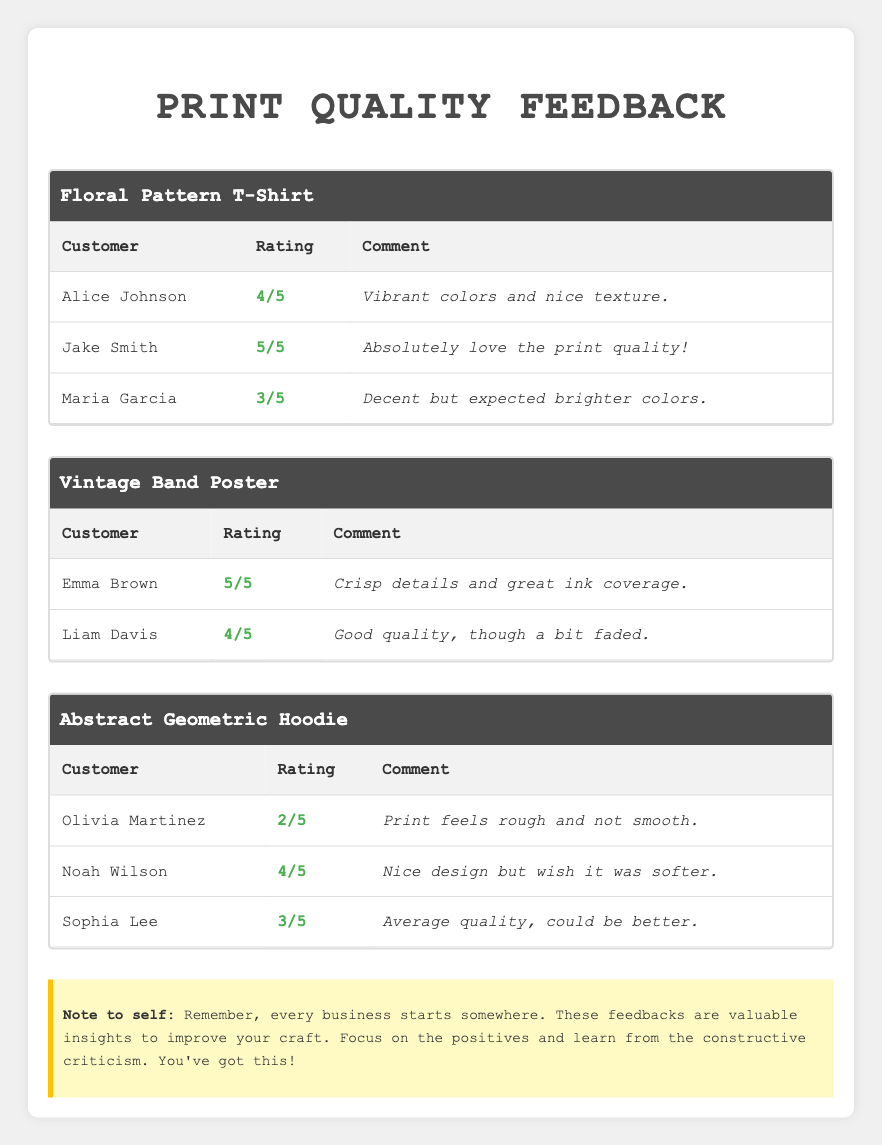What is the highest rating given to a design? The highest rating in the feedback table is 5, which was given by Jake Smith for the 'Floral Pattern T-Shirt' and by Emma Brown for the 'Vintage Band Poster'.
Answer: 5 How many customer feedbacks are there for the 'Abstract Geometric Hoodie'? There are three customer feedback entries for the 'Abstract Geometric Hoodie', from Olivia Martinez, Noah Wilson, and Sophia Lee.
Answer: 3 Which design received an average rating of 3 or higher? To find this out, we sum the ratings for each design. 'Floral Pattern T-Shirt' has ratings of 4, 5, and 3 (average: 4). 'Vintage Band Poster' has ratings of 5 and 4 (average: 4.5). 'Abstract Geometric Hoodie' has ratings of 2, 4, and 3 (average: 3). Thus, both 'Floral Pattern T-Shirt' and 'Vintage Band Poster' received an average rating of 3 or higher.
Answer: Floral Pattern T-Shirt, Vintage Band Poster Did anyone give a rating of 1 for any design? By checking the ratings provided by customers, the lowest rating given is 2 for the 'Abstract Geometric Hoodie', which means no one gave a rating of 1.
Answer: No What is the average rating for the 'Floral Pattern T-Shirt'? The ratings for the 'Floral Pattern T-Shirt' are 4, 5, and 3. To find the average, we add these ratings: 4 + 5 + 3 = 12, and then divide by the number of ratings, which is 3. So, the average is 12 / 3 = 4.
Answer: 4 Which customer's feedback includes a negative comment about the texture of their print? Olivia Martinez gave a rating of 2 for the 'Abstract Geometric Hoodie' and commented that the "print feels rough and not smooth," indicating dissatisfaction with the texture.
Answer: Olivia Martinez How many customers rated the 'Vintage Band Poster'? The 'Vintage Band Poster' received feedback from two customers: Emma Brown and Liam Davis.
Answer: 2 What is the total sum of all ratings for the 'Abstract Geometric Hoodie'? For the 'Abstract Geometric Hoodie', the ratings are 2, 4, and 3. Adding these together gives 2 + 4 + 3 = 9, which is the total sum of ratings.
Answer: 9 